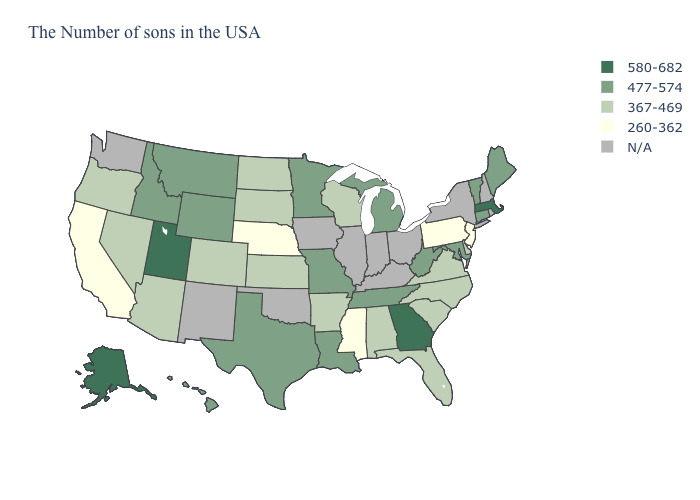Among the states that border California , which have the highest value?
Keep it brief. Arizona, Nevada, Oregon. How many symbols are there in the legend?
Short answer required. 5. What is the value of California?
Short answer required. 260-362. What is the lowest value in states that border Maryland?
Short answer required. 260-362. What is the highest value in the USA?
Answer briefly. 580-682. Which states have the highest value in the USA?
Give a very brief answer. Massachusetts, Georgia, Utah, Alaska. Name the states that have a value in the range 260-362?
Quick response, please. New Jersey, Pennsylvania, Mississippi, Nebraska, California. Among the states that border Minnesota , which have the highest value?
Quick response, please. Wisconsin, South Dakota, North Dakota. Name the states that have a value in the range 367-469?
Concise answer only. Delaware, Virginia, North Carolina, South Carolina, Florida, Alabama, Wisconsin, Arkansas, Kansas, South Dakota, North Dakota, Colorado, Arizona, Nevada, Oregon. What is the highest value in the MidWest ?
Keep it brief. 477-574. What is the value of Minnesota?
Give a very brief answer. 477-574. Among the states that border Pennsylvania , which have the highest value?
Concise answer only. Maryland, West Virginia. 